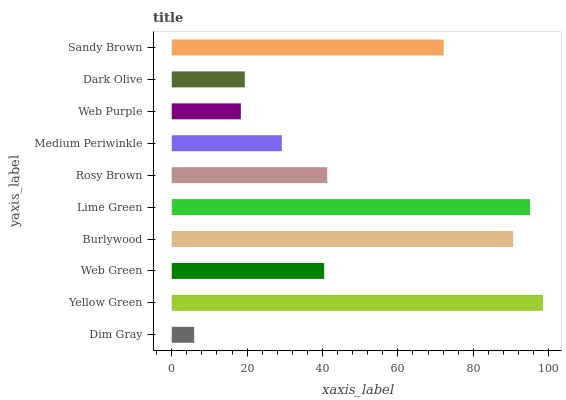Is Dim Gray the minimum?
Answer yes or no. Yes. Is Yellow Green the maximum?
Answer yes or no. Yes. Is Web Green the minimum?
Answer yes or no. No. Is Web Green the maximum?
Answer yes or no. No. Is Yellow Green greater than Web Green?
Answer yes or no. Yes. Is Web Green less than Yellow Green?
Answer yes or no. Yes. Is Web Green greater than Yellow Green?
Answer yes or no. No. Is Yellow Green less than Web Green?
Answer yes or no. No. Is Rosy Brown the high median?
Answer yes or no. Yes. Is Web Green the low median?
Answer yes or no. Yes. Is Medium Periwinkle the high median?
Answer yes or no. No. Is Burlywood the low median?
Answer yes or no. No. 